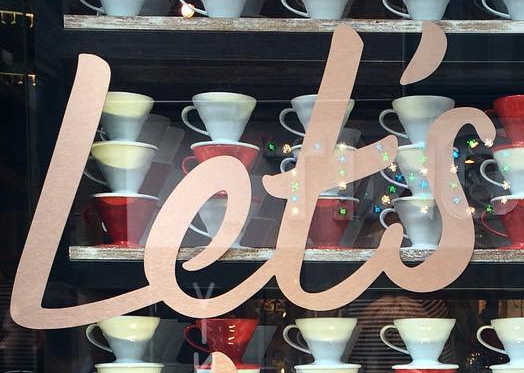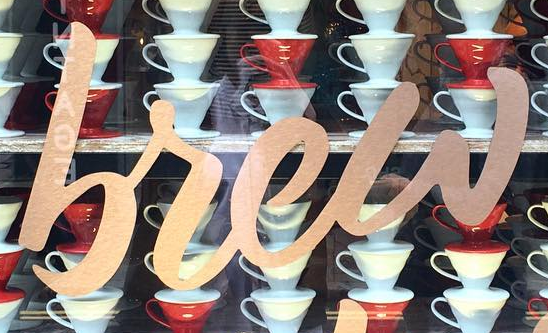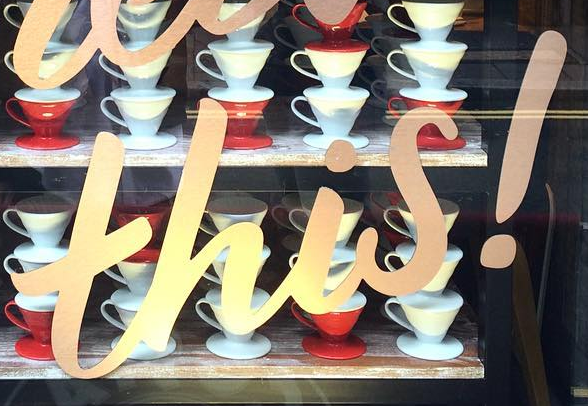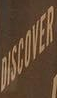Read the text content from these images in order, separated by a semicolon. Let's; brew; this!; DISCOVER 